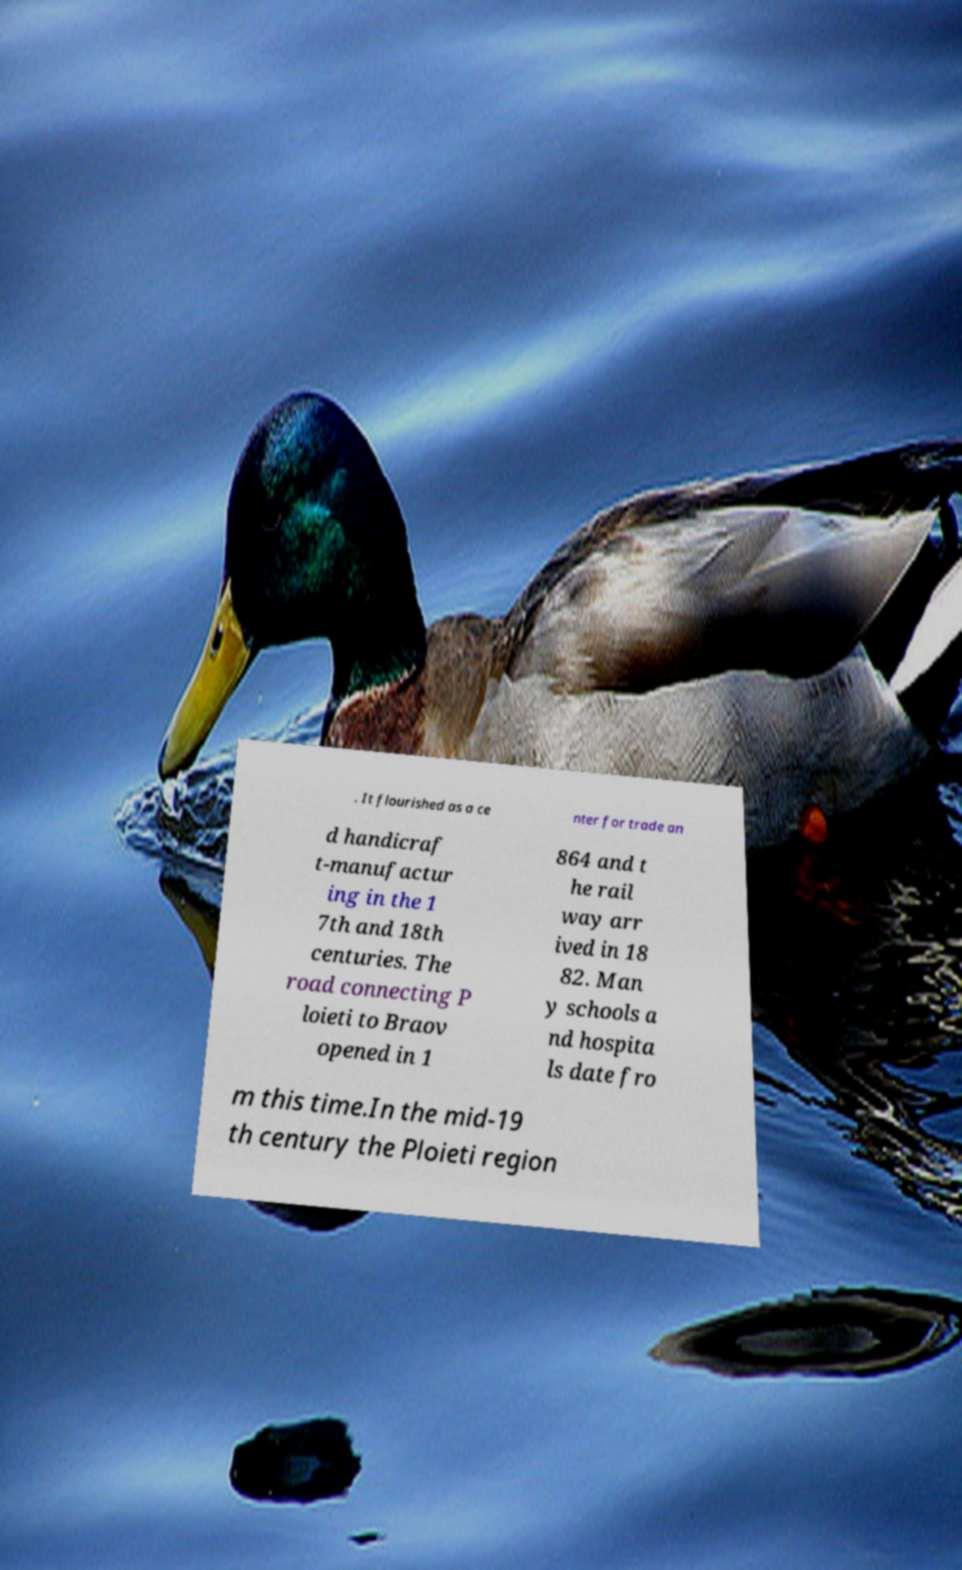Could you assist in decoding the text presented in this image and type it out clearly? . It flourished as a ce nter for trade an d handicraf t-manufactur ing in the 1 7th and 18th centuries. The road connecting P loieti to Braov opened in 1 864 and t he rail way arr ived in 18 82. Man y schools a nd hospita ls date fro m this time.In the mid-19 th century the Ploieti region 